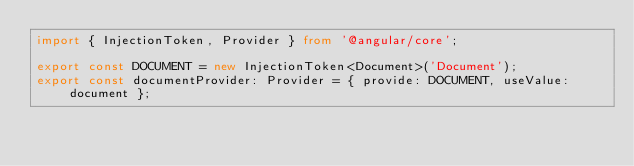Convert code to text. <code><loc_0><loc_0><loc_500><loc_500><_TypeScript_>import { InjectionToken, Provider } from '@angular/core';

export const DOCUMENT = new InjectionToken<Document>('Document');
export const documentProvider: Provider = { provide: DOCUMENT, useValue: document };
</code> 